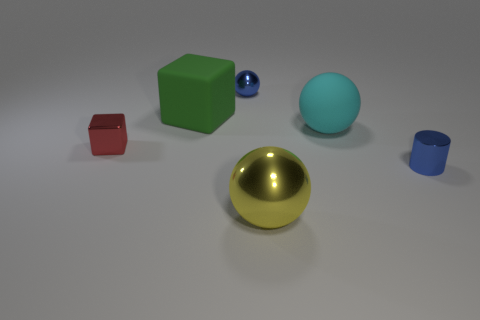Is there a blue sphere of the same size as the yellow thing?
Provide a succinct answer. No. There is a thing in front of the small blue thing that is on the right side of the small blue thing behind the small cylinder; what is its material?
Make the answer very short. Metal. What number of small shiny spheres are to the left of the matte object on the right side of the big shiny object?
Your response must be concise. 1. Does the blue metal object behind the red shiny thing have the same size as the yellow metallic sphere?
Keep it short and to the point. No. What number of other tiny things have the same shape as the cyan matte object?
Your answer should be compact. 1. What is the shape of the red object?
Make the answer very short. Cube. Are there an equal number of objects behind the green rubber thing and green cubes?
Give a very brief answer. Yes. Are the block that is behind the cyan sphere and the red block made of the same material?
Your response must be concise. No. Are there fewer green blocks that are in front of the tiny metallic block than purple cubes?
Provide a succinct answer. No. How many rubber objects are either red objects or large cubes?
Provide a short and direct response. 1. 